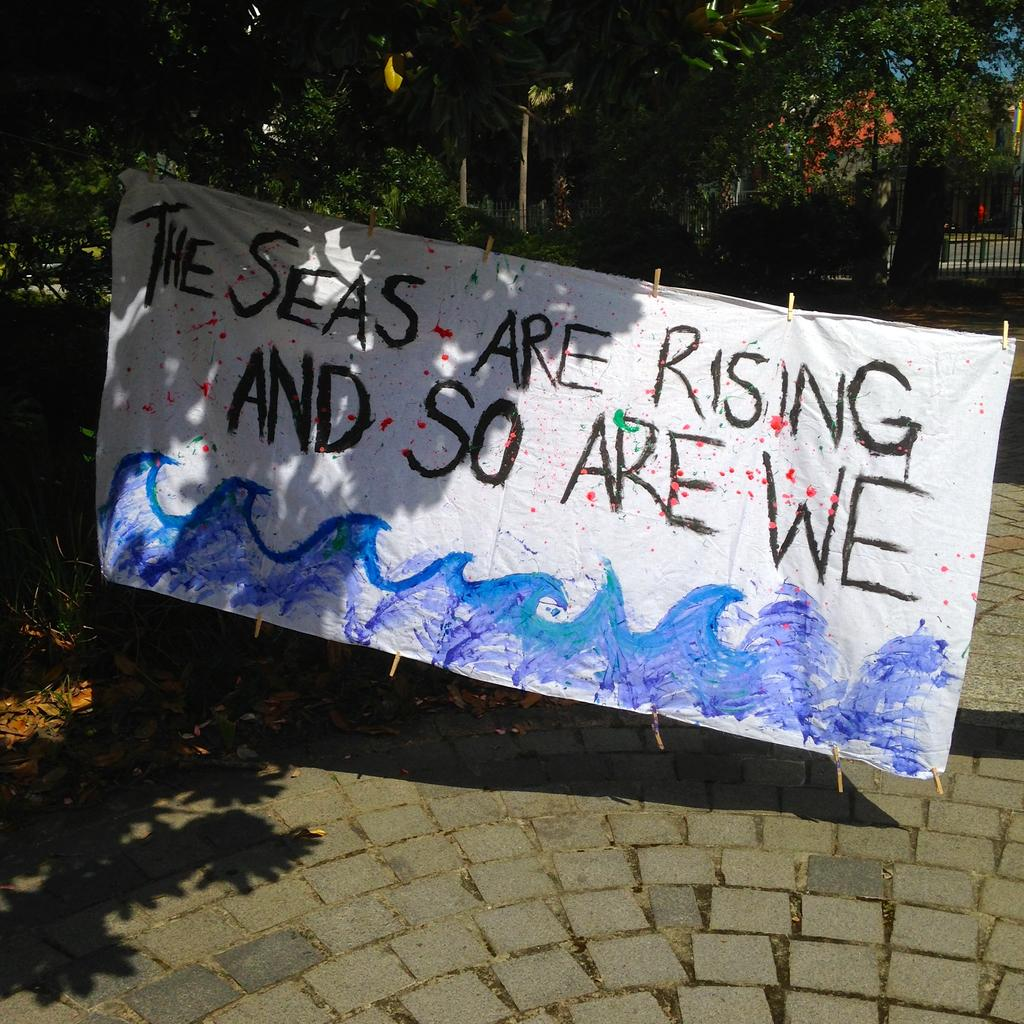What is the main subject in the center of the image? There is a poster in the center of the image. What message does the poster convey? The poster has text that says "the seas are rising". What can be seen on the right side of the image? There is a boundary on the right side of the image. How many cakes are displayed on the poster in the image? There are no cakes present on the poster in the image; it features text about rising seas. 